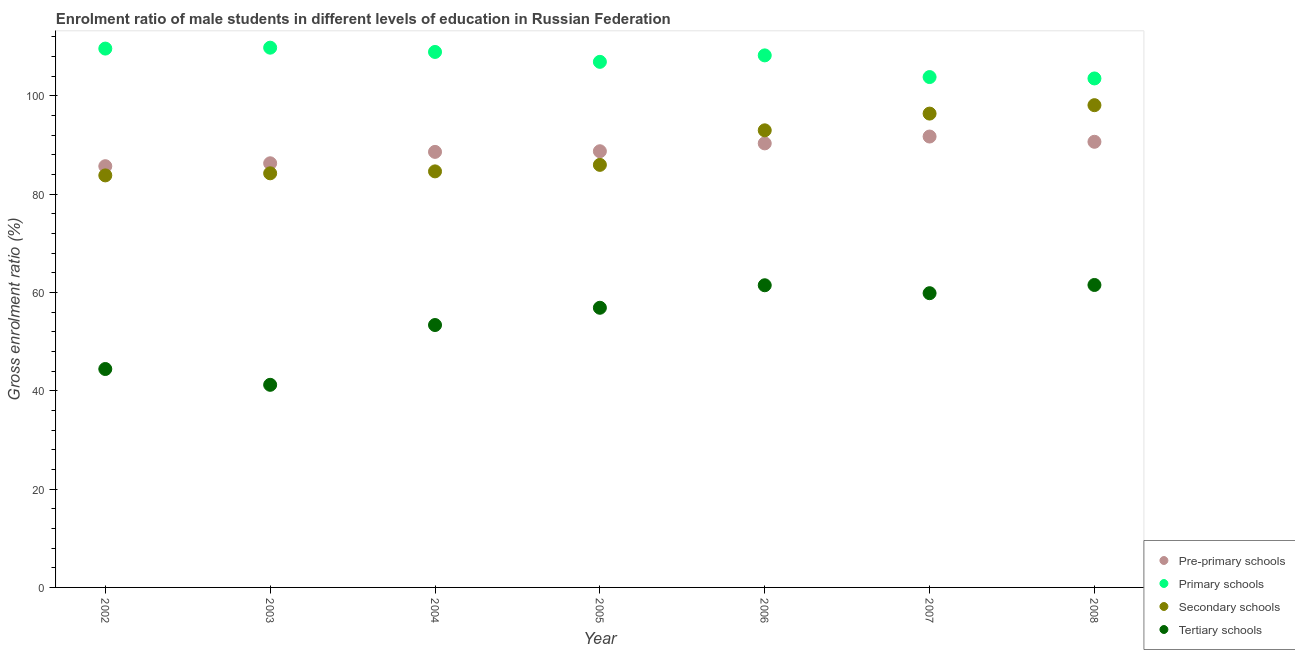How many different coloured dotlines are there?
Provide a short and direct response. 4. Is the number of dotlines equal to the number of legend labels?
Offer a terse response. Yes. What is the gross enrolment ratio(female) in pre-primary schools in 2005?
Your response must be concise. 88.73. Across all years, what is the maximum gross enrolment ratio(female) in pre-primary schools?
Provide a short and direct response. 91.72. Across all years, what is the minimum gross enrolment ratio(female) in primary schools?
Provide a succinct answer. 103.53. In which year was the gross enrolment ratio(female) in secondary schools maximum?
Keep it short and to the point. 2008. In which year was the gross enrolment ratio(female) in pre-primary schools minimum?
Keep it short and to the point. 2002. What is the total gross enrolment ratio(female) in tertiary schools in the graph?
Your answer should be compact. 378.75. What is the difference between the gross enrolment ratio(female) in primary schools in 2005 and that in 2008?
Your response must be concise. 3.38. What is the difference between the gross enrolment ratio(female) in tertiary schools in 2003 and the gross enrolment ratio(female) in secondary schools in 2004?
Ensure brevity in your answer.  -43.42. What is the average gross enrolment ratio(female) in secondary schools per year?
Keep it short and to the point. 89.44. In the year 2007, what is the difference between the gross enrolment ratio(female) in primary schools and gross enrolment ratio(female) in secondary schools?
Offer a terse response. 7.43. In how many years, is the gross enrolment ratio(female) in secondary schools greater than 96 %?
Ensure brevity in your answer.  2. What is the ratio of the gross enrolment ratio(female) in pre-primary schools in 2004 to that in 2006?
Your answer should be compact. 0.98. Is the gross enrolment ratio(female) in secondary schools in 2005 less than that in 2008?
Make the answer very short. Yes. Is the difference between the gross enrolment ratio(female) in secondary schools in 2002 and 2007 greater than the difference between the gross enrolment ratio(female) in tertiary schools in 2002 and 2007?
Provide a succinct answer. Yes. What is the difference between the highest and the second highest gross enrolment ratio(female) in secondary schools?
Keep it short and to the point. 1.71. What is the difference between the highest and the lowest gross enrolment ratio(female) in primary schools?
Ensure brevity in your answer.  6.26. In how many years, is the gross enrolment ratio(female) in primary schools greater than the average gross enrolment ratio(female) in primary schools taken over all years?
Ensure brevity in your answer.  4. Is it the case that in every year, the sum of the gross enrolment ratio(female) in pre-primary schools and gross enrolment ratio(female) in primary schools is greater than the gross enrolment ratio(female) in secondary schools?
Keep it short and to the point. Yes. Does the gross enrolment ratio(female) in pre-primary schools monotonically increase over the years?
Offer a terse response. No. How many dotlines are there?
Ensure brevity in your answer.  4. Are the values on the major ticks of Y-axis written in scientific E-notation?
Your answer should be compact. No. Does the graph contain any zero values?
Keep it short and to the point. No. Where does the legend appear in the graph?
Keep it short and to the point. Bottom right. What is the title of the graph?
Your answer should be very brief. Enrolment ratio of male students in different levels of education in Russian Federation. Does "Argument" appear as one of the legend labels in the graph?
Offer a terse response. No. What is the Gross enrolment ratio (%) of Pre-primary schools in 2002?
Your response must be concise. 85.69. What is the Gross enrolment ratio (%) in Primary schools in 2002?
Offer a terse response. 109.61. What is the Gross enrolment ratio (%) in Secondary schools in 2002?
Keep it short and to the point. 83.81. What is the Gross enrolment ratio (%) in Tertiary schools in 2002?
Provide a succinct answer. 44.43. What is the Gross enrolment ratio (%) of Pre-primary schools in 2003?
Your response must be concise. 86.28. What is the Gross enrolment ratio (%) in Primary schools in 2003?
Make the answer very short. 109.79. What is the Gross enrolment ratio (%) of Secondary schools in 2003?
Keep it short and to the point. 84.24. What is the Gross enrolment ratio (%) in Tertiary schools in 2003?
Your answer should be very brief. 41.21. What is the Gross enrolment ratio (%) in Pre-primary schools in 2004?
Your response must be concise. 88.6. What is the Gross enrolment ratio (%) of Primary schools in 2004?
Ensure brevity in your answer.  108.93. What is the Gross enrolment ratio (%) in Secondary schools in 2004?
Offer a very short reply. 84.63. What is the Gross enrolment ratio (%) in Tertiary schools in 2004?
Offer a terse response. 53.38. What is the Gross enrolment ratio (%) of Pre-primary schools in 2005?
Your answer should be compact. 88.73. What is the Gross enrolment ratio (%) in Primary schools in 2005?
Offer a terse response. 106.91. What is the Gross enrolment ratio (%) of Secondary schools in 2005?
Keep it short and to the point. 85.96. What is the Gross enrolment ratio (%) of Tertiary schools in 2005?
Give a very brief answer. 56.89. What is the Gross enrolment ratio (%) in Pre-primary schools in 2006?
Give a very brief answer. 90.33. What is the Gross enrolment ratio (%) of Primary schools in 2006?
Your answer should be very brief. 108.23. What is the Gross enrolment ratio (%) of Secondary schools in 2006?
Your answer should be compact. 92.98. What is the Gross enrolment ratio (%) of Tertiary schools in 2006?
Make the answer very short. 61.47. What is the Gross enrolment ratio (%) in Pre-primary schools in 2007?
Your response must be concise. 91.72. What is the Gross enrolment ratio (%) in Primary schools in 2007?
Your answer should be compact. 103.82. What is the Gross enrolment ratio (%) in Secondary schools in 2007?
Your answer should be compact. 96.38. What is the Gross enrolment ratio (%) of Tertiary schools in 2007?
Your answer should be compact. 59.85. What is the Gross enrolment ratio (%) of Pre-primary schools in 2008?
Ensure brevity in your answer.  90.65. What is the Gross enrolment ratio (%) in Primary schools in 2008?
Your response must be concise. 103.53. What is the Gross enrolment ratio (%) in Secondary schools in 2008?
Provide a succinct answer. 98.1. What is the Gross enrolment ratio (%) in Tertiary schools in 2008?
Ensure brevity in your answer.  61.52. Across all years, what is the maximum Gross enrolment ratio (%) in Pre-primary schools?
Provide a short and direct response. 91.72. Across all years, what is the maximum Gross enrolment ratio (%) of Primary schools?
Provide a succinct answer. 109.79. Across all years, what is the maximum Gross enrolment ratio (%) in Secondary schools?
Offer a very short reply. 98.1. Across all years, what is the maximum Gross enrolment ratio (%) in Tertiary schools?
Make the answer very short. 61.52. Across all years, what is the minimum Gross enrolment ratio (%) in Pre-primary schools?
Provide a succinct answer. 85.69. Across all years, what is the minimum Gross enrolment ratio (%) in Primary schools?
Offer a terse response. 103.53. Across all years, what is the minimum Gross enrolment ratio (%) of Secondary schools?
Your answer should be very brief. 83.81. Across all years, what is the minimum Gross enrolment ratio (%) of Tertiary schools?
Ensure brevity in your answer.  41.21. What is the total Gross enrolment ratio (%) of Pre-primary schools in the graph?
Your response must be concise. 621.99. What is the total Gross enrolment ratio (%) in Primary schools in the graph?
Give a very brief answer. 750.82. What is the total Gross enrolment ratio (%) in Secondary schools in the graph?
Provide a succinct answer. 626.11. What is the total Gross enrolment ratio (%) in Tertiary schools in the graph?
Give a very brief answer. 378.75. What is the difference between the Gross enrolment ratio (%) in Pre-primary schools in 2002 and that in 2003?
Provide a short and direct response. -0.59. What is the difference between the Gross enrolment ratio (%) of Primary schools in 2002 and that in 2003?
Your answer should be very brief. -0.18. What is the difference between the Gross enrolment ratio (%) of Secondary schools in 2002 and that in 2003?
Keep it short and to the point. -0.42. What is the difference between the Gross enrolment ratio (%) in Tertiary schools in 2002 and that in 2003?
Make the answer very short. 3.22. What is the difference between the Gross enrolment ratio (%) of Pre-primary schools in 2002 and that in 2004?
Provide a succinct answer. -2.91. What is the difference between the Gross enrolment ratio (%) in Primary schools in 2002 and that in 2004?
Keep it short and to the point. 0.68. What is the difference between the Gross enrolment ratio (%) in Secondary schools in 2002 and that in 2004?
Give a very brief answer. -0.82. What is the difference between the Gross enrolment ratio (%) of Tertiary schools in 2002 and that in 2004?
Keep it short and to the point. -8.95. What is the difference between the Gross enrolment ratio (%) in Pre-primary schools in 2002 and that in 2005?
Give a very brief answer. -3.04. What is the difference between the Gross enrolment ratio (%) of Primary schools in 2002 and that in 2005?
Provide a succinct answer. 2.7. What is the difference between the Gross enrolment ratio (%) in Secondary schools in 2002 and that in 2005?
Keep it short and to the point. -2.14. What is the difference between the Gross enrolment ratio (%) in Tertiary schools in 2002 and that in 2005?
Make the answer very short. -12.46. What is the difference between the Gross enrolment ratio (%) of Pre-primary schools in 2002 and that in 2006?
Make the answer very short. -4.64. What is the difference between the Gross enrolment ratio (%) in Primary schools in 2002 and that in 2006?
Your response must be concise. 1.38. What is the difference between the Gross enrolment ratio (%) of Secondary schools in 2002 and that in 2006?
Offer a terse response. -9.17. What is the difference between the Gross enrolment ratio (%) in Tertiary schools in 2002 and that in 2006?
Give a very brief answer. -17.04. What is the difference between the Gross enrolment ratio (%) in Pre-primary schools in 2002 and that in 2007?
Ensure brevity in your answer.  -6.03. What is the difference between the Gross enrolment ratio (%) in Primary schools in 2002 and that in 2007?
Your response must be concise. 5.79. What is the difference between the Gross enrolment ratio (%) in Secondary schools in 2002 and that in 2007?
Your answer should be compact. -12.57. What is the difference between the Gross enrolment ratio (%) in Tertiary schools in 2002 and that in 2007?
Offer a terse response. -15.42. What is the difference between the Gross enrolment ratio (%) in Pre-primary schools in 2002 and that in 2008?
Offer a terse response. -4.96. What is the difference between the Gross enrolment ratio (%) of Primary schools in 2002 and that in 2008?
Provide a succinct answer. 6.08. What is the difference between the Gross enrolment ratio (%) in Secondary schools in 2002 and that in 2008?
Provide a succinct answer. -14.28. What is the difference between the Gross enrolment ratio (%) of Tertiary schools in 2002 and that in 2008?
Offer a very short reply. -17.09. What is the difference between the Gross enrolment ratio (%) of Pre-primary schools in 2003 and that in 2004?
Your answer should be very brief. -2.32. What is the difference between the Gross enrolment ratio (%) in Primary schools in 2003 and that in 2004?
Your response must be concise. 0.87. What is the difference between the Gross enrolment ratio (%) in Secondary schools in 2003 and that in 2004?
Provide a short and direct response. -0.39. What is the difference between the Gross enrolment ratio (%) of Tertiary schools in 2003 and that in 2004?
Provide a succinct answer. -12.16. What is the difference between the Gross enrolment ratio (%) in Pre-primary schools in 2003 and that in 2005?
Give a very brief answer. -2.45. What is the difference between the Gross enrolment ratio (%) in Primary schools in 2003 and that in 2005?
Keep it short and to the point. 2.88. What is the difference between the Gross enrolment ratio (%) in Secondary schools in 2003 and that in 2005?
Keep it short and to the point. -1.72. What is the difference between the Gross enrolment ratio (%) of Tertiary schools in 2003 and that in 2005?
Your answer should be compact. -15.67. What is the difference between the Gross enrolment ratio (%) of Pre-primary schools in 2003 and that in 2006?
Your answer should be very brief. -4.05. What is the difference between the Gross enrolment ratio (%) of Primary schools in 2003 and that in 2006?
Make the answer very short. 1.57. What is the difference between the Gross enrolment ratio (%) in Secondary schools in 2003 and that in 2006?
Offer a terse response. -8.75. What is the difference between the Gross enrolment ratio (%) in Tertiary schools in 2003 and that in 2006?
Your answer should be compact. -20.25. What is the difference between the Gross enrolment ratio (%) of Pre-primary schools in 2003 and that in 2007?
Keep it short and to the point. -5.44. What is the difference between the Gross enrolment ratio (%) in Primary schools in 2003 and that in 2007?
Keep it short and to the point. 5.97. What is the difference between the Gross enrolment ratio (%) of Secondary schools in 2003 and that in 2007?
Give a very brief answer. -12.15. What is the difference between the Gross enrolment ratio (%) in Tertiary schools in 2003 and that in 2007?
Provide a short and direct response. -18.64. What is the difference between the Gross enrolment ratio (%) of Pre-primary schools in 2003 and that in 2008?
Give a very brief answer. -4.37. What is the difference between the Gross enrolment ratio (%) in Primary schools in 2003 and that in 2008?
Your response must be concise. 6.26. What is the difference between the Gross enrolment ratio (%) in Secondary schools in 2003 and that in 2008?
Make the answer very short. -13.86. What is the difference between the Gross enrolment ratio (%) of Tertiary schools in 2003 and that in 2008?
Make the answer very short. -20.31. What is the difference between the Gross enrolment ratio (%) in Pre-primary schools in 2004 and that in 2005?
Provide a succinct answer. -0.13. What is the difference between the Gross enrolment ratio (%) in Primary schools in 2004 and that in 2005?
Ensure brevity in your answer.  2.01. What is the difference between the Gross enrolment ratio (%) in Secondary schools in 2004 and that in 2005?
Your answer should be very brief. -1.32. What is the difference between the Gross enrolment ratio (%) in Tertiary schools in 2004 and that in 2005?
Offer a very short reply. -3.51. What is the difference between the Gross enrolment ratio (%) of Pre-primary schools in 2004 and that in 2006?
Make the answer very short. -1.73. What is the difference between the Gross enrolment ratio (%) in Primary schools in 2004 and that in 2006?
Offer a very short reply. 0.7. What is the difference between the Gross enrolment ratio (%) in Secondary schools in 2004 and that in 2006?
Offer a very short reply. -8.35. What is the difference between the Gross enrolment ratio (%) of Tertiary schools in 2004 and that in 2006?
Make the answer very short. -8.09. What is the difference between the Gross enrolment ratio (%) in Pre-primary schools in 2004 and that in 2007?
Offer a very short reply. -3.12. What is the difference between the Gross enrolment ratio (%) of Primary schools in 2004 and that in 2007?
Offer a terse response. 5.11. What is the difference between the Gross enrolment ratio (%) in Secondary schools in 2004 and that in 2007?
Keep it short and to the point. -11.75. What is the difference between the Gross enrolment ratio (%) in Tertiary schools in 2004 and that in 2007?
Provide a short and direct response. -6.48. What is the difference between the Gross enrolment ratio (%) in Pre-primary schools in 2004 and that in 2008?
Provide a succinct answer. -2.05. What is the difference between the Gross enrolment ratio (%) of Primary schools in 2004 and that in 2008?
Your answer should be very brief. 5.39. What is the difference between the Gross enrolment ratio (%) of Secondary schools in 2004 and that in 2008?
Your response must be concise. -13.47. What is the difference between the Gross enrolment ratio (%) in Tertiary schools in 2004 and that in 2008?
Your answer should be very brief. -8.15. What is the difference between the Gross enrolment ratio (%) in Pre-primary schools in 2005 and that in 2006?
Ensure brevity in your answer.  -1.6. What is the difference between the Gross enrolment ratio (%) of Primary schools in 2005 and that in 2006?
Your answer should be compact. -1.32. What is the difference between the Gross enrolment ratio (%) in Secondary schools in 2005 and that in 2006?
Give a very brief answer. -7.03. What is the difference between the Gross enrolment ratio (%) in Tertiary schools in 2005 and that in 2006?
Your answer should be compact. -4.58. What is the difference between the Gross enrolment ratio (%) in Pre-primary schools in 2005 and that in 2007?
Offer a very short reply. -2.99. What is the difference between the Gross enrolment ratio (%) of Primary schools in 2005 and that in 2007?
Keep it short and to the point. 3.09. What is the difference between the Gross enrolment ratio (%) in Secondary schools in 2005 and that in 2007?
Your answer should be very brief. -10.43. What is the difference between the Gross enrolment ratio (%) in Tertiary schools in 2005 and that in 2007?
Give a very brief answer. -2.97. What is the difference between the Gross enrolment ratio (%) of Pre-primary schools in 2005 and that in 2008?
Your answer should be compact. -1.92. What is the difference between the Gross enrolment ratio (%) in Primary schools in 2005 and that in 2008?
Offer a very short reply. 3.38. What is the difference between the Gross enrolment ratio (%) in Secondary schools in 2005 and that in 2008?
Keep it short and to the point. -12.14. What is the difference between the Gross enrolment ratio (%) in Tertiary schools in 2005 and that in 2008?
Make the answer very short. -4.64. What is the difference between the Gross enrolment ratio (%) of Pre-primary schools in 2006 and that in 2007?
Provide a short and direct response. -1.39. What is the difference between the Gross enrolment ratio (%) of Primary schools in 2006 and that in 2007?
Offer a very short reply. 4.41. What is the difference between the Gross enrolment ratio (%) of Secondary schools in 2006 and that in 2007?
Provide a short and direct response. -3.4. What is the difference between the Gross enrolment ratio (%) of Tertiary schools in 2006 and that in 2007?
Give a very brief answer. 1.61. What is the difference between the Gross enrolment ratio (%) in Pre-primary schools in 2006 and that in 2008?
Offer a terse response. -0.32. What is the difference between the Gross enrolment ratio (%) of Primary schools in 2006 and that in 2008?
Provide a succinct answer. 4.69. What is the difference between the Gross enrolment ratio (%) of Secondary schools in 2006 and that in 2008?
Ensure brevity in your answer.  -5.12. What is the difference between the Gross enrolment ratio (%) in Tertiary schools in 2006 and that in 2008?
Keep it short and to the point. -0.06. What is the difference between the Gross enrolment ratio (%) in Pre-primary schools in 2007 and that in 2008?
Offer a very short reply. 1.07. What is the difference between the Gross enrolment ratio (%) in Primary schools in 2007 and that in 2008?
Your answer should be compact. 0.28. What is the difference between the Gross enrolment ratio (%) of Secondary schools in 2007 and that in 2008?
Your answer should be very brief. -1.71. What is the difference between the Gross enrolment ratio (%) of Tertiary schools in 2007 and that in 2008?
Your answer should be very brief. -1.67. What is the difference between the Gross enrolment ratio (%) in Pre-primary schools in 2002 and the Gross enrolment ratio (%) in Primary schools in 2003?
Your answer should be very brief. -24.11. What is the difference between the Gross enrolment ratio (%) in Pre-primary schools in 2002 and the Gross enrolment ratio (%) in Secondary schools in 2003?
Make the answer very short. 1.45. What is the difference between the Gross enrolment ratio (%) of Pre-primary schools in 2002 and the Gross enrolment ratio (%) of Tertiary schools in 2003?
Your answer should be very brief. 44.47. What is the difference between the Gross enrolment ratio (%) in Primary schools in 2002 and the Gross enrolment ratio (%) in Secondary schools in 2003?
Offer a very short reply. 25.37. What is the difference between the Gross enrolment ratio (%) in Primary schools in 2002 and the Gross enrolment ratio (%) in Tertiary schools in 2003?
Ensure brevity in your answer.  68.4. What is the difference between the Gross enrolment ratio (%) of Secondary schools in 2002 and the Gross enrolment ratio (%) of Tertiary schools in 2003?
Provide a short and direct response. 42.6. What is the difference between the Gross enrolment ratio (%) of Pre-primary schools in 2002 and the Gross enrolment ratio (%) of Primary schools in 2004?
Your response must be concise. -23.24. What is the difference between the Gross enrolment ratio (%) of Pre-primary schools in 2002 and the Gross enrolment ratio (%) of Secondary schools in 2004?
Your response must be concise. 1.05. What is the difference between the Gross enrolment ratio (%) in Pre-primary schools in 2002 and the Gross enrolment ratio (%) in Tertiary schools in 2004?
Make the answer very short. 32.31. What is the difference between the Gross enrolment ratio (%) in Primary schools in 2002 and the Gross enrolment ratio (%) in Secondary schools in 2004?
Keep it short and to the point. 24.98. What is the difference between the Gross enrolment ratio (%) of Primary schools in 2002 and the Gross enrolment ratio (%) of Tertiary schools in 2004?
Ensure brevity in your answer.  56.23. What is the difference between the Gross enrolment ratio (%) of Secondary schools in 2002 and the Gross enrolment ratio (%) of Tertiary schools in 2004?
Make the answer very short. 30.44. What is the difference between the Gross enrolment ratio (%) in Pre-primary schools in 2002 and the Gross enrolment ratio (%) in Primary schools in 2005?
Your response must be concise. -21.23. What is the difference between the Gross enrolment ratio (%) of Pre-primary schools in 2002 and the Gross enrolment ratio (%) of Secondary schools in 2005?
Provide a succinct answer. -0.27. What is the difference between the Gross enrolment ratio (%) of Pre-primary schools in 2002 and the Gross enrolment ratio (%) of Tertiary schools in 2005?
Your answer should be compact. 28.8. What is the difference between the Gross enrolment ratio (%) in Primary schools in 2002 and the Gross enrolment ratio (%) in Secondary schools in 2005?
Your answer should be compact. 23.65. What is the difference between the Gross enrolment ratio (%) in Primary schools in 2002 and the Gross enrolment ratio (%) in Tertiary schools in 2005?
Offer a very short reply. 52.72. What is the difference between the Gross enrolment ratio (%) of Secondary schools in 2002 and the Gross enrolment ratio (%) of Tertiary schools in 2005?
Offer a terse response. 26.93. What is the difference between the Gross enrolment ratio (%) of Pre-primary schools in 2002 and the Gross enrolment ratio (%) of Primary schools in 2006?
Your answer should be very brief. -22.54. What is the difference between the Gross enrolment ratio (%) of Pre-primary schools in 2002 and the Gross enrolment ratio (%) of Secondary schools in 2006?
Ensure brevity in your answer.  -7.3. What is the difference between the Gross enrolment ratio (%) of Pre-primary schools in 2002 and the Gross enrolment ratio (%) of Tertiary schools in 2006?
Offer a very short reply. 24.22. What is the difference between the Gross enrolment ratio (%) in Primary schools in 2002 and the Gross enrolment ratio (%) in Secondary schools in 2006?
Offer a very short reply. 16.63. What is the difference between the Gross enrolment ratio (%) of Primary schools in 2002 and the Gross enrolment ratio (%) of Tertiary schools in 2006?
Provide a succinct answer. 48.14. What is the difference between the Gross enrolment ratio (%) in Secondary schools in 2002 and the Gross enrolment ratio (%) in Tertiary schools in 2006?
Your answer should be very brief. 22.35. What is the difference between the Gross enrolment ratio (%) in Pre-primary schools in 2002 and the Gross enrolment ratio (%) in Primary schools in 2007?
Your answer should be very brief. -18.13. What is the difference between the Gross enrolment ratio (%) of Pre-primary schools in 2002 and the Gross enrolment ratio (%) of Secondary schools in 2007?
Make the answer very short. -10.7. What is the difference between the Gross enrolment ratio (%) of Pre-primary schools in 2002 and the Gross enrolment ratio (%) of Tertiary schools in 2007?
Provide a short and direct response. 25.83. What is the difference between the Gross enrolment ratio (%) in Primary schools in 2002 and the Gross enrolment ratio (%) in Secondary schools in 2007?
Give a very brief answer. 13.23. What is the difference between the Gross enrolment ratio (%) in Primary schools in 2002 and the Gross enrolment ratio (%) in Tertiary schools in 2007?
Your answer should be compact. 49.76. What is the difference between the Gross enrolment ratio (%) of Secondary schools in 2002 and the Gross enrolment ratio (%) of Tertiary schools in 2007?
Make the answer very short. 23.96. What is the difference between the Gross enrolment ratio (%) in Pre-primary schools in 2002 and the Gross enrolment ratio (%) in Primary schools in 2008?
Your answer should be very brief. -17.85. What is the difference between the Gross enrolment ratio (%) of Pre-primary schools in 2002 and the Gross enrolment ratio (%) of Secondary schools in 2008?
Your answer should be very brief. -12.41. What is the difference between the Gross enrolment ratio (%) in Pre-primary schools in 2002 and the Gross enrolment ratio (%) in Tertiary schools in 2008?
Ensure brevity in your answer.  24.16. What is the difference between the Gross enrolment ratio (%) of Primary schools in 2002 and the Gross enrolment ratio (%) of Secondary schools in 2008?
Give a very brief answer. 11.51. What is the difference between the Gross enrolment ratio (%) in Primary schools in 2002 and the Gross enrolment ratio (%) in Tertiary schools in 2008?
Keep it short and to the point. 48.09. What is the difference between the Gross enrolment ratio (%) in Secondary schools in 2002 and the Gross enrolment ratio (%) in Tertiary schools in 2008?
Provide a succinct answer. 22.29. What is the difference between the Gross enrolment ratio (%) in Pre-primary schools in 2003 and the Gross enrolment ratio (%) in Primary schools in 2004?
Offer a very short reply. -22.65. What is the difference between the Gross enrolment ratio (%) in Pre-primary schools in 2003 and the Gross enrolment ratio (%) in Secondary schools in 2004?
Make the answer very short. 1.65. What is the difference between the Gross enrolment ratio (%) of Pre-primary schools in 2003 and the Gross enrolment ratio (%) of Tertiary schools in 2004?
Your response must be concise. 32.9. What is the difference between the Gross enrolment ratio (%) in Primary schools in 2003 and the Gross enrolment ratio (%) in Secondary schools in 2004?
Your answer should be compact. 25.16. What is the difference between the Gross enrolment ratio (%) of Primary schools in 2003 and the Gross enrolment ratio (%) of Tertiary schools in 2004?
Offer a terse response. 56.42. What is the difference between the Gross enrolment ratio (%) of Secondary schools in 2003 and the Gross enrolment ratio (%) of Tertiary schools in 2004?
Provide a succinct answer. 30.86. What is the difference between the Gross enrolment ratio (%) of Pre-primary schools in 2003 and the Gross enrolment ratio (%) of Primary schools in 2005?
Your response must be concise. -20.63. What is the difference between the Gross enrolment ratio (%) in Pre-primary schools in 2003 and the Gross enrolment ratio (%) in Secondary schools in 2005?
Your response must be concise. 0.32. What is the difference between the Gross enrolment ratio (%) in Pre-primary schools in 2003 and the Gross enrolment ratio (%) in Tertiary schools in 2005?
Give a very brief answer. 29.39. What is the difference between the Gross enrolment ratio (%) in Primary schools in 2003 and the Gross enrolment ratio (%) in Secondary schools in 2005?
Your answer should be very brief. 23.84. What is the difference between the Gross enrolment ratio (%) of Primary schools in 2003 and the Gross enrolment ratio (%) of Tertiary schools in 2005?
Your response must be concise. 52.91. What is the difference between the Gross enrolment ratio (%) of Secondary schools in 2003 and the Gross enrolment ratio (%) of Tertiary schools in 2005?
Make the answer very short. 27.35. What is the difference between the Gross enrolment ratio (%) in Pre-primary schools in 2003 and the Gross enrolment ratio (%) in Primary schools in 2006?
Provide a succinct answer. -21.95. What is the difference between the Gross enrolment ratio (%) in Pre-primary schools in 2003 and the Gross enrolment ratio (%) in Secondary schools in 2006?
Your answer should be compact. -6.7. What is the difference between the Gross enrolment ratio (%) in Pre-primary schools in 2003 and the Gross enrolment ratio (%) in Tertiary schools in 2006?
Ensure brevity in your answer.  24.81. What is the difference between the Gross enrolment ratio (%) in Primary schools in 2003 and the Gross enrolment ratio (%) in Secondary schools in 2006?
Your answer should be compact. 16.81. What is the difference between the Gross enrolment ratio (%) in Primary schools in 2003 and the Gross enrolment ratio (%) in Tertiary schools in 2006?
Offer a very short reply. 48.33. What is the difference between the Gross enrolment ratio (%) in Secondary schools in 2003 and the Gross enrolment ratio (%) in Tertiary schools in 2006?
Ensure brevity in your answer.  22.77. What is the difference between the Gross enrolment ratio (%) in Pre-primary schools in 2003 and the Gross enrolment ratio (%) in Primary schools in 2007?
Provide a short and direct response. -17.54. What is the difference between the Gross enrolment ratio (%) in Pre-primary schools in 2003 and the Gross enrolment ratio (%) in Secondary schools in 2007?
Your response must be concise. -10.11. What is the difference between the Gross enrolment ratio (%) of Pre-primary schools in 2003 and the Gross enrolment ratio (%) of Tertiary schools in 2007?
Provide a short and direct response. 26.43. What is the difference between the Gross enrolment ratio (%) of Primary schools in 2003 and the Gross enrolment ratio (%) of Secondary schools in 2007?
Ensure brevity in your answer.  13.41. What is the difference between the Gross enrolment ratio (%) of Primary schools in 2003 and the Gross enrolment ratio (%) of Tertiary schools in 2007?
Ensure brevity in your answer.  49.94. What is the difference between the Gross enrolment ratio (%) of Secondary schools in 2003 and the Gross enrolment ratio (%) of Tertiary schools in 2007?
Ensure brevity in your answer.  24.38. What is the difference between the Gross enrolment ratio (%) in Pre-primary schools in 2003 and the Gross enrolment ratio (%) in Primary schools in 2008?
Make the answer very short. -17.26. What is the difference between the Gross enrolment ratio (%) in Pre-primary schools in 2003 and the Gross enrolment ratio (%) in Secondary schools in 2008?
Ensure brevity in your answer.  -11.82. What is the difference between the Gross enrolment ratio (%) in Pre-primary schools in 2003 and the Gross enrolment ratio (%) in Tertiary schools in 2008?
Provide a succinct answer. 24.76. What is the difference between the Gross enrolment ratio (%) in Primary schools in 2003 and the Gross enrolment ratio (%) in Secondary schools in 2008?
Ensure brevity in your answer.  11.69. What is the difference between the Gross enrolment ratio (%) in Primary schools in 2003 and the Gross enrolment ratio (%) in Tertiary schools in 2008?
Offer a terse response. 48.27. What is the difference between the Gross enrolment ratio (%) in Secondary schools in 2003 and the Gross enrolment ratio (%) in Tertiary schools in 2008?
Keep it short and to the point. 22.71. What is the difference between the Gross enrolment ratio (%) of Pre-primary schools in 2004 and the Gross enrolment ratio (%) of Primary schools in 2005?
Make the answer very short. -18.31. What is the difference between the Gross enrolment ratio (%) in Pre-primary schools in 2004 and the Gross enrolment ratio (%) in Secondary schools in 2005?
Make the answer very short. 2.64. What is the difference between the Gross enrolment ratio (%) of Pre-primary schools in 2004 and the Gross enrolment ratio (%) of Tertiary schools in 2005?
Make the answer very short. 31.71. What is the difference between the Gross enrolment ratio (%) of Primary schools in 2004 and the Gross enrolment ratio (%) of Secondary schools in 2005?
Provide a succinct answer. 22.97. What is the difference between the Gross enrolment ratio (%) in Primary schools in 2004 and the Gross enrolment ratio (%) in Tertiary schools in 2005?
Your answer should be compact. 52.04. What is the difference between the Gross enrolment ratio (%) of Secondary schools in 2004 and the Gross enrolment ratio (%) of Tertiary schools in 2005?
Provide a short and direct response. 27.74. What is the difference between the Gross enrolment ratio (%) of Pre-primary schools in 2004 and the Gross enrolment ratio (%) of Primary schools in 2006?
Your response must be concise. -19.63. What is the difference between the Gross enrolment ratio (%) in Pre-primary schools in 2004 and the Gross enrolment ratio (%) in Secondary schools in 2006?
Your answer should be compact. -4.39. What is the difference between the Gross enrolment ratio (%) in Pre-primary schools in 2004 and the Gross enrolment ratio (%) in Tertiary schools in 2006?
Your response must be concise. 27.13. What is the difference between the Gross enrolment ratio (%) in Primary schools in 2004 and the Gross enrolment ratio (%) in Secondary schools in 2006?
Ensure brevity in your answer.  15.94. What is the difference between the Gross enrolment ratio (%) in Primary schools in 2004 and the Gross enrolment ratio (%) in Tertiary schools in 2006?
Provide a succinct answer. 47.46. What is the difference between the Gross enrolment ratio (%) in Secondary schools in 2004 and the Gross enrolment ratio (%) in Tertiary schools in 2006?
Give a very brief answer. 23.16. What is the difference between the Gross enrolment ratio (%) in Pre-primary schools in 2004 and the Gross enrolment ratio (%) in Primary schools in 2007?
Offer a very short reply. -15.22. What is the difference between the Gross enrolment ratio (%) of Pre-primary schools in 2004 and the Gross enrolment ratio (%) of Secondary schools in 2007?
Provide a succinct answer. -7.79. What is the difference between the Gross enrolment ratio (%) in Pre-primary schools in 2004 and the Gross enrolment ratio (%) in Tertiary schools in 2007?
Provide a short and direct response. 28.74. What is the difference between the Gross enrolment ratio (%) of Primary schools in 2004 and the Gross enrolment ratio (%) of Secondary schools in 2007?
Offer a very short reply. 12.54. What is the difference between the Gross enrolment ratio (%) of Primary schools in 2004 and the Gross enrolment ratio (%) of Tertiary schools in 2007?
Make the answer very short. 49.07. What is the difference between the Gross enrolment ratio (%) in Secondary schools in 2004 and the Gross enrolment ratio (%) in Tertiary schools in 2007?
Ensure brevity in your answer.  24.78. What is the difference between the Gross enrolment ratio (%) in Pre-primary schools in 2004 and the Gross enrolment ratio (%) in Primary schools in 2008?
Offer a terse response. -14.94. What is the difference between the Gross enrolment ratio (%) of Pre-primary schools in 2004 and the Gross enrolment ratio (%) of Secondary schools in 2008?
Keep it short and to the point. -9.5. What is the difference between the Gross enrolment ratio (%) of Pre-primary schools in 2004 and the Gross enrolment ratio (%) of Tertiary schools in 2008?
Provide a short and direct response. 27.07. What is the difference between the Gross enrolment ratio (%) of Primary schools in 2004 and the Gross enrolment ratio (%) of Secondary schools in 2008?
Your answer should be compact. 10.83. What is the difference between the Gross enrolment ratio (%) of Primary schools in 2004 and the Gross enrolment ratio (%) of Tertiary schools in 2008?
Offer a very short reply. 47.4. What is the difference between the Gross enrolment ratio (%) in Secondary schools in 2004 and the Gross enrolment ratio (%) in Tertiary schools in 2008?
Make the answer very short. 23.11. What is the difference between the Gross enrolment ratio (%) in Pre-primary schools in 2005 and the Gross enrolment ratio (%) in Primary schools in 2006?
Provide a short and direct response. -19.5. What is the difference between the Gross enrolment ratio (%) in Pre-primary schools in 2005 and the Gross enrolment ratio (%) in Secondary schools in 2006?
Keep it short and to the point. -4.25. What is the difference between the Gross enrolment ratio (%) of Pre-primary schools in 2005 and the Gross enrolment ratio (%) of Tertiary schools in 2006?
Give a very brief answer. 27.26. What is the difference between the Gross enrolment ratio (%) in Primary schools in 2005 and the Gross enrolment ratio (%) in Secondary schools in 2006?
Provide a succinct answer. 13.93. What is the difference between the Gross enrolment ratio (%) of Primary schools in 2005 and the Gross enrolment ratio (%) of Tertiary schools in 2006?
Ensure brevity in your answer.  45.44. What is the difference between the Gross enrolment ratio (%) of Secondary schools in 2005 and the Gross enrolment ratio (%) of Tertiary schools in 2006?
Give a very brief answer. 24.49. What is the difference between the Gross enrolment ratio (%) in Pre-primary schools in 2005 and the Gross enrolment ratio (%) in Primary schools in 2007?
Offer a very short reply. -15.09. What is the difference between the Gross enrolment ratio (%) in Pre-primary schools in 2005 and the Gross enrolment ratio (%) in Secondary schools in 2007?
Make the answer very short. -7.66. What is the difference between the Gross enrolment ratio (%) of Pre-primary schools in 2005 and the Gross enrolment ratio (%) of Tertiary schools in 2007?
Offer a very short reply. 28.88. What is the difference between the Gross enrolment ratio (%) of Primary schools in 2005 and the Gross enrolment ratio (%) of Secondary schools in 2007?
Your answer should be very brief. 10.53. What is the difference between the Gross enrolment ratio (%) of Primary schools in 2005 and the Gross enrolment ratio (%) of Tertiary schools in 2007?
Your response must be concise. 47.06. What is the difference between the Gross enrolment ratio (%) of Secondary schools in 2005 and the Gross enrolment ratio (%) of Tertiary schools in 2007?
Keep it short and to the point. 26.1. What is the difference between the Gross enrolment ratio (%) of Pre-primary schools in 2005 and the Gross enrolment ratio (%) of Primary schools in 2008?
Provide a short and direct response. -14.81. What is the difference between the Gross enrolment ratio (%) of Pre-primary schools in 2005 and the Gross enrolment ratio (%) of Secondary schools in 2008?
Provide a succinct answer. -9.37. What is the difference between the Gross enrolment ratio (%) of Pre-primary schools in 2005 and the Gross enrolment ratio (%) of Tertiary schools in 2008?
Your answer should be very brief. 27.2. What is the difference between the Gross enrolment ratio (%) of Primary schools in 2005 and the Gross enrolment ratio (%) of Secondary schools in 2008?
Provide a short and direct response. 8.81. What is the difference between the Gross enrolment ratio (%) of Primary schools in 2005 and the Gross enrolment ratio (%) of Tertiary schools in 2008?
Provide a succinct answer. 45.39. What is the difference between the Gross enrolment ratio (%) in Secondary schools in 2005 and the Gross enrolment ratio (%) in Tertiary schools in 2008?
Keep it short and to the point. 24.43. What is the difference between the Gross enrolment ratio (%) of Pre-primary schools in 2006 and the Gross enrolment ratio (%) of Primary schools in 2007?
Provide a succinct answer. -13.49. What is the difference between the Gross enrolment ratio (%) in Pre-primary schools in 2006 and the Gross enrolment ratio (%) in Secondary schools in 2007?
Offer a very short reply. -6.06. What is the difference between the Gross enrolment ratio (%) of Pre-primary schools in 2006 and the Gross enrolment ratio (%) of Tertiary schools in 2007?
Keep it short and to the point. 30.47. What is the difference between the Gross enrolment ratio (%) in Primary schools in 2006 and the Gross enrolment ratio (%) in Secondary schools in 2007?
Provide a succinct answer. 11.84. What is the difference between the Gross enrolment ratio (%) in Primary schools in 2006 and the Gross enrolment ratio (%) in Tertiary schools in 2007?
Your response must be concise. 48.37. What is the difference between the Gross enrolment ratio (%) in Secondary schools in 2006 and the Gross enrolment ratio (%) in Tertiary schools in 2007?
Provide a short and direct response. 33.13. What is the difference between the Gross enrolment ratio (%) in Pre-primary schools in 2006 and the Gross enrolment ratio (%) in Primary schools in 2008?
Ensure brevity in your answer.  -13.21. What is the difference between the Gross enrolment ratio (%) of Pre-primary schools in 2006 and the Gross enrolment ratio (%) of Secondary schools in 2008?
Give a very brief answer. -7.77. What is the difference between the Gross enrolment ratio (%) of Pre-primary schools in 2006 and the Gross enrolment ratio (%) of Tertiary schools in 2008?
Offer a very short reply. 28.8. What is the difference between the Gross enrolment ratio (%) of Primary schools in 2006 and the Gross enrolment ratio (%) of Secondary schools in 2008?
Make the answer very short. 10.13. What is the difference between the Gross enrolment ratio (%) in Primary schools in 2006 and the Gross enrolment ratio (%) in Tertiary schools in 2008?
Your answer should be very brief. 46.7. What is the difference between the Gross enrolment ratio (%) of Secondary schools in 2006 and the Gross enrolment ratio (%) of Tertiary schools in 2008?
Give a very brief answer. 31.46. What is the difference between the Gross enrolment ratio (%) of Pre-primary schools in 2007 and the Gross enrolment ratio (%) of Primary schools in 2008?
Your answer should be compact. -11.82. What is the difference between the Gross enrolment ratio (%) of Pre-primary schools in 2007 and the Gross enrolment ratio (%) of Secondary schools in 2008?
Provide a short and direct response. -6.38. What is the difference between the Gross enrolment ratio (%) of Pre-primary schools in 2007 and the Gross enrolment ratio (%) of Tertiary schools in 2008?
Make the answer very short. 30.2. What is the difference between the Gross enrolment ratio (%) in Primary schools in 2007 and the Gross enrolment ratio (%) in Secondary schools in 2008?
Make the answer very short. 5.72. What is the difference between the Gross enrolment ratio (%) of Primary schools in 2007 and the Gross enrolment ratio (%) of Tertiary schools in 2008?
Your answer should be compact. 42.3. What is the difference between the Gross enrolment ratio (%) in Secondary schools in 2007 and the Gross enrolment ratio (%) in Tertiary schools in 2008?
Give a very brief answer. 34.86. What is the average Gross enrolment ratio (%) of Pre-primary schools per year?
Your answer should be very brief. 88.86. What is the average Gross enrolment ratio (%) of Primary schools per year?
Offer a terse response. 107.26. What is the average Gross enrolment ratio (%) in Secondary schools per year?
Ensure brevity in your answer.  89.44. What is the average Gross enrolment ratio (%) in Tertiary schools per year?
Give a very brief answer. 54.11. In the year 2002, what is the difference between the Gross enrolment ratio (%) of Pre-primary schools and Gross enrolment ratio (%) of Primary schools?
Make the answer very short. -23.92. In the year 2002, what is the difference between the Gross enrolment ratio (%) in Pre-primary schools and Gross enrolment ratio (%) in Secondary schools?
Keep it short and to the point. 1.87. In the year 2002, what is the difference between the Gross enrolment ratio (%) in Pre-primary schools and Gross enrolment ratio (%) in Tertiary schools?
Offer a very short reply. 41.26. In the year 2002, what is the difference between the Gross enrolment ratio (%) of Primary schools and Gross enrolment ratio (%) of Secondary schools?
Your answer should be compact. 25.8. In the year 2002, what is the difference between the Gross enrolment ratio (%) in Primary schools and Gross enrolment ratio (%) in Tertiary schools?
Provide a short and direct response. 65.18. In the year 2002, what is the difference between the Gross enrolment ratio (%) in Secondary schools and Gross enrolment ratio (%) in Tertiary schools?
Your answer should be compact. 39.38. In the year 2003, what is the difference between the Gross enrolment ratio (%) in Pre-primary schools and Gross enrolment ratio (%) in Primary schools?
Ensure brevity in your answer.  -23.51. In the year 2003, what is the difference between the Gross enrolment ratio (%) in Pre-primary schools and Gross enrolment ratio (%) in Secondary schools?
Keep it short and to the point. 2.04. In the year 2003, what is the difference between the Gross enrolment ratio (%) of Pre-primary schools and Gross enrolment ratio (%) of Tertiary schools?
Make the answer very short. 45.07. In the year 2003, what is the difference between the Gross enrolment ratio (%) of Primary schools and Gross enrolment ratio (%) of Secondary schools?
Ensure brevity in your answer.  25.56. In the year 2003, what is the difference between the Gross enrolment ratio (%) of Primary schools and Gross enrolment ratio (%) of Tertiary schools?
Your answer should be very brief. 68.58. In the year 2003, what is the difference between the Gross enrolment ratio (%) in Secondary schools and Gross enrolment ratio (%) in Tertiary schools?
Provide a succinct answer. 43.02. In the year 2004, what is the difference between the Gross enrolment ratio (%) of Pre-primary schools and Gross enrolment ratio (%) of Primary schools?
Offer a very short reply. -20.33. In the year 2004, what is the difference between the Gross enrolment ratio (%) in Pre-primary schools and Gross enrolment ratio (%) in Secondary schools?
Offer a terse response. 3.97. In the year 2004, what is the difference between the Gross enrolment ratio (%) of Pre-primary schools and Gross enrolment ratio (%) of Tertiary schools?
Keep it short and to the point. 35.22. In the year 2004, what is the difference between the Gross enrolment ratio (%) in Primary schools and Gross enrolment ratio (%) in Secondary schools?
Offer a very short reply. 24.29. In the year 2004, what is the difference between the Gross enrolment ratio (%) of Primary schools and Gross enrolment ratio (%) of Tertiary schools?
Make the answer very short. 55.55. In the year 2004, what is the difference between the Gross enrolment ratio (%) of Secondary schools and Gross enrolment ratio (%) of Tertiary schools?
Give a very brief answer. 31.25. In the year 2005, what is the difference between the Gross enrolment ratio (%) in Pre-primary schools and Gross enrolment ratio (%) in Primary schools?
Your answer should be compact. -18.18. In the year 2005, what is the difference between the Gross enrolment ratio (%) in Pre-primary schools and Gross enrolment ratio (%) in Secondary schools?
Your response must be concise. 2.77. In the year 2005, what is the difference between the Gross enrolment ratio (%) in Pre-primary schools and Gross enrolment ratio (%) in Tertiary schools?
Your answer should be compact. 31.84. In the year 2005, what is the difference between the Gross enrolment ratio (%) of Primary schools and Gross enrolment ratio (%) of Secondary schools?
Provide a succinct answer. 20.96. In the year 2005, what is the difference between the Gross enrolment ratio (%) of Primary schools and Gross enrolment ratio (%) of Tertiary schools?
Provide a succinct answer. 50.03. In the year 2005, what is the difference between the Gross enrolment ratio (%) in Secondary schools and Gross enrolment ratio (%) in Tertiary schools?
Offer a very short reply. 29.07. In the year 2006, what is the difference between the Gross enrolment ratio (%) of Pre-primary schools and Gross enrolment ratio (%) of Primary schools?
Provide a short and direct response. -17.9. In the year 2006, what is the difference between the Gross enrolment ratio (%) of Pre-primary schools and Gross enrolment ratio (%) of Secondary schools?
Give a very brief answer. -2.66. In the year 2006, what is the difference between the Gross enrolment ratio (%) in Pre-primary schools and Gross enrolment ratio (%) in Tertiary schools?
Make the answer very short. 28.86. In the year 2006, what is the difference between the Gross enrolment ratio (%) in Primary schools and Gross enrolment ratio (%) in Secondary schools?
Provide a short and direct response. 15.24. In the year 2006, what is the difference between the Gross enrolment ratio (%) in Primary schools and Gross enrolment ratio (%) in Tertiary schools?
Give a very brief answer. 46.76. In the year 2006, what is the difference between the Gross enrolment ratio (%) in Secondary schools and Gross enrolment ratio (%) in Tertiary schools?
Make the answer very short. 31.52. In the year 2007, what is the difference between the Gross enrolment ratio (%) of Pre-primary schools and Gross enrolment ratio (%) of Primary schools?
Make the answer very short. -12.1. In the year 2007, what is the difference between the Gross enrolment ratio (%) in Pre-primary schools and Gross enrolment ratio (%) in Secondary schools?
Provide a succinct answer. -4.67. In the year 2007, what is the difference between the Gross enrolment ratio (%) in Pre-primary schools and Gross enrolment ratio (%) in Tertiary schools?
Give a very brief answer. 31.87. In the year 2007, what is the difference between the Gross enrolment ratio (%) in Primary schools and Gross enrolment ratio (%) in Secondary schools?
Give a very brief answer. 7.43. In the year 2007, what is the difference between the Gross enrolment ratio (%) in Primary schools and Gross enrolment ratio (%) in Tertiary schools?
Provide a succinct answer. 43.97. In the year 2007, what is the difference between the Gross enrolment ratio (%) in Secondary schools and Gross enrolment ratio (%) in Tertiary schools?
Provide a short and direct response. 36.53. In the year 2008, what is the difference between the Gross enrolment ratio (%) of Pre-primary schools and Gross enrolment ratio (%) of Primary schools?
Provide a succinct answer. -12.88. In the year 2008, what is the difference between the Gross enrolment ratio (%) in Pre-primary schools and Gross enrolment ratio (%) in Secondary schools?
Give a very brief answer. -7.45. In the year 2008, what is the difference between the Gross enrolment ratio (%) of Pre-primary schools and Gross enrolment ratio (%) of Tertiary schools?
Your answer should be very brief. 29.13. In the year 2008, what is the difference between the Gross enrolment ratio (%) of Primary schools and Gross enrolment ratio (%) of Secondary schools?
Your answer should be very brief. 5.44. In the year 2008, what is the difference between the Gross enrolment ratio (%) in Primary schools and Gross enrolment ratio (%) in Tertiary schools?
Provide a succinct answer. 42.01. In the year 2008, what is the difference between the Gross enrolment ratio (%) in Secondary schools and Gross enrolment ratio (%) in Tertiary schools?
Give a very brief answer. 36.58. What is the ratio of the Gross enrolment ratio (%) of Pre-primary schools in 2002 to that in 2003?
Make the answer very short. 0.99. What is the ratio of the Gross enrolment ratio (%) of Secondary schools in 2002 to that in 2003?
Provide a short and direct response. 0.99. What is the ratio of the Gross enrolment ratio (%) of Tertiary schools in 2002 to that in 2003?
Offer a very short reply. 1.08. What is the ratio of the Gross enrolment ratio (%) of Pre-primary schools in 2002 to that in 2004?
Ensure brevity in your answer.  0.97. What is the ratio of the Gross enrolment ratio (%) in Primary schools in 2002 to that in 2004?
Make the answer very short. 1.01. What is the ratio of the Gross enrolment ratio (%) in Secondary schools in 2002 to that in 2004?
Give a very brief answer. 0.99. What is the ratio of the Gross enrolment ratio (%) in Tertiary schools in 2002 to that in 2004?
Make the answer very short. 0.83. What is the ratio of the Gross enrolment ratio (%) of Pre-primary schools in 2002 to that in 2005?
Your response must be concise. 0.97. What is the ratio of the Gross enrolment ratio (%) in Primary schools in 2002 to that in 2005?
Provide a succinct answer. 1.03. What is the ratio of the Gross enrolment ratio (%) of Secondary schools in 2002 to that in 2005?
Your answer should be compact. 0.98. What is the ratio of the Gross enrolment ratio (%) of Tertiary schools in 2002 to that in 2005?
Keep it short and to the point. 0.78. What is the ratio of the Gross enrolment ratio (%) in Pre-primary schools in 2002 to that in 2006?
Give a very brief answer. 0.95. What is the ratio of the Gross enrolment ratio (%) in Primary schools in 2002 to that in 2006?
Offer a terse response. 1.01. What is the ratio of the Gross enrolment ratio (%) in Secondary schools in 2002 to that in 2006?
Keep it short and to the point. 0.9. What is the ratio of the Gross enrolment ratio (%) in Tertiary schools in 2002 to that in 2006?
Make the answer very short. 0.72. What is the ratio of the Gross enrolment ratio (%) of Pre-primary schools in 2002 to that in 2007?
Make the answer very short. 0.93. What is the ratio of the Gross enrolment ratio (%) in Primary schools in 2002 to that in 2007?
Keep it short and to the point. 1.06. What is the ratio of the Gross enrolment ratio (%) in Secondary schools in 2002 to that in 2007?
Your answer should be very brief. 0.87. What is the ratio of the Gross enrolment ratio (%) of Tertiary schools in 2002 to that in 2007?
Offer a very short reply. 0.74. What is the ratio of the Gross enrolment ratio (%) in Pre-primary schools in 2002 to that in 2008?
Your answer should be very brief. 0.95. What is the ratio of the Gross enrolment ratio (%) of Primary schools in 2002 to that in 2008?
Offer a terse response. 1.06. What is the ratio of the Gross enrolment ratio (%) of Secondary schools in 2002 to that in 2008?
Provide a succinct answer. 0.85. What is the ratio of the Gross enrolment ratio (%) of Tertiary schools in 2002 to that in 2008?
Offer a very short reply. 0.72. What is the ratio of the Gross enrolment ratio (%) in Pre-primary schools in 2003 to that in 2004?
Make the answer very short. 0.97. What is the ratio of the Gross enrolment ratio (%) in Primary schools in 2003 to that in 2004?
Your answer should be compact. 1.01. What is the ratio of the Gross enrolment ratio (%) in Secondary schools in 2003 to that in 2004?
Your answer should be compact. 1. What is the ratio of the Gross enrolment ratio (%) in Tertiary schools in 2003 to that in 2004?
Provide a succinct answer. 0.77. What is the ratio of the Gross enrolment ratio (%) in Pre-primary schools in 2003 to that in 2005?
Make the answer very short. 0.97. What is the ratio of the Gross enrolment ratio (%) in Primary schools in 2003 to that in 2005?
Your answer should be compact. 1.03. What is the ratio of the Gross enrolment ratio (%) in Secondary schools in 2003 to that in 2005?
Give a very brief answer. 0.98. What is the ratio of the Gross enrolment ratio (%) in Tertiary schools in 2003 to that in 2005?
Your answer should be very brief. 0.72. What is the ratio of the Gross enrolment ratio (%) of Pre-primary schools in 2003 to that in 2006?
Give a very brief answer. 0.96. What is the ratio of the Gross enrolment ratio (%) in Primary schools in 2003 to that in 2006?
Give a very brief answer. 1.01. What is the ratio of the Gross enrolment ratio (%) of Secondary schools in 2003 to that in 2006?
Provide a succinct answer. 0.91. What is the ratio of the Gross enrolment ratio (%) in Tertiary schools in 2003 to that in 2006?
Provide a succinct answer. 0.67. What is the ratio of the Gross enrolment ratio (%) in Pre-primary schools in 2003 to that in 2007?
Provide a succinct answer. 0.94. What is the ratio of the Gross enrolment ratio (%) in Primary schools in 2003 to that in 2007?
Ensure brevity in your answer.  1.06. What is the ratio of the Gross enrolment ratio (%) in Secondary schools in 2003 to that in 2007?
Your response must be concise. 0.87. What is the ratio of the Gross enrolment ratio (%) of Tertiary schools in 2003 to that in 2007?
Give a very brief answer. 0.69. What is the ratio of the Gross enrolment ratio (%) of Pre-primary schools in 2003 to that in 2008?
Give a very brief answer. 0.95. What is the ratio of the Gross enrolment ratio (%) in Primary schools in 2003 to that in 2008?
Your answer should be compact. 1.06. What is the ratio of the Gross enrolment ratio (%) of Secondary schools in 2003 to that in 2008?
Your answer should be compact. 0.86. What is the ratio of the Gross enrolment ratio (%) of Tertiary schools in 2003 to that in 2008?
Give a very brief answer. 0.67. What is the ratio of the Gross enrolment ratio (%) in Primary schools in 2004 to that in 2005?
Make the answer very short. 1.02. What is the ratio of the Gross enrolment ratio (%) in Secondary schools in 2004 to that in 2005?
Your answer should be compact. 0.98. What is the ratio of the Gross enrolment ratio (%) of Tertiary schools in 2004 to that in 2005?
Offer a very short reply. 0.94. What is the ratio of the Gross enrolment ratio (%) in Pre-primary schools in 2004 to that in 2006?
Your response must be concise. 0.98. What is the ratio of the Gross enrolment ratio (%) in Secondary schools in 2004 to that in 2006?
Offer a terse response. 0.91. What is the ratio of the Gross enrolment ratio (%) of Tertiary schools in 2004 to that in 2006?
Provide a succinct answer. 0.87. What is the ratio of the Gross enrolment ratio (%) of Pre-primary schools in 2004 to that in 2007?
Your answer should be compact. 0.97. What is the ratio of the Gross enrolment ratio (%) in Primary schools in 2004 to that in 2007?
Give a very brief answer. 1.05. What is the ratio of the Gross enrolment ratio (%) of Secondary schools in 2004 to that in 2007?
Give a very brief answer. 0.88. What is the ratio of the Gross enrolment ratio (%) of Tertiary schools in 2004 to that in 2007?
Provide a succinct answer. 0.89. What is the ratio of the Gross enrolment ratio (%) in Pre-primary schools in 2004 to that in 2008?
Provide a short and direct response. 0.98. What is the ratio of the Gross enrolment ratio (%) of Primary schools in 2004 to that in 2008?
Your answer should be very brief. 1.05. What is the ratio of the Gross enrolment ratio (%) of Secondary schools in 2004 to that in 2008?
Provide a succinct answer. 0.86. What is the ratio of the Gross enrolment ratio (%) of Tertiary schools in 2004 to that in 2008?
Keep it short and to the point. 0.87. What is the ratio of the Gross enrolment ratio (%) of Pre-primary schools in 2005 to that in 2006?
Ensure brevity in your answer.  0.98. What is the ratio of the Gross enrolment ratio (%) in Primary schools in 2005 to that in 2006?
Offer a very short reply. 0.99. What is the ratio of the Gross enrolment ratio (%) in Secondary schools in 2005 to that in 2006?
Your response must be concise. 0.92. What is the ratio of the Gross enrolment ratio (%) in Tertiary schools in 2005 to that in 2006?
Provide a short and direct response. 0.93. What is the ratio of the Gross enrolment ratio (%) in Pre-primary schools in 2005 to that in 2007?
Provide a short and direct response. 0.97. What is the ratio of the Gross enrolment ratio (%) in Primary schools in 2005 to that in 2007?
Your answer should be very brief. 1.03. What is the ratio of the Gross enrolment ratio (%) of Secondary schools in 2005 to that in 2007?
Make the answer very short. 0.89. What is the ratio of the Gross enrolment ratio (%) of Tertiary schools in 2005 to that in 2007?
Offer a very short reply. 0.95. What is the ratio of the Gross enrolment ratio (%) in Pre-primary schools in 2005 to that in 2008?
Provide a short and direct response. 0.98. What is the ratio of the Gross enrolment ratio (%) in Primary schools in 2005 to that in 2008?
Your answer should be compact. 1.03. What is the ratio of the Gross enrolment ratio (%) in Secondary schools in 2005 to that in 2008?
Offer a terse response. 0.88. What is the ratio of the Gross enrolment ratio (%) of Tertiary schools in 2005 to that in 2008?
Provide a short and direct response. 0.92. What is the ratio of the Gross enrolment ratio (%) in Pre-primary schools in 2006 to that in 2007?
Your answer should be compact. 0.98. What is the ratio of the Gross enrolment ratio (%) in Primary schools in 2006 to that in 2007?
Your answer should be very brief. 1.04. What is the ratio of the Gross enrolment ratio (%) in Secondary schools in 2006 to that in 2007?
Offer a terse response. 0.96. What is the ratio of the Gross enrolment ratio (%) of Tertiary schools in 2006 to that in 2007?
Offer a very short reply. 1.03. What is the ratio of the Gross enrolment ratio (%) in Primary schools in 2006 to that in 2008?
Your response must be concise. 1.05. What is the ratio of the Gross enrolment ratio (%) in Secondary schools in 2006 to that in 2008?
Ensure brevity in your answer.  0.95. What is the ratio of the Gross enrolment ratio (%) of Pre-primary schools in 2007 to that in 2008?
Offer a very short reply. 1.01. What is the ratio of the Gross enrolment ratio (%) in Secondary schools in 2007 to that in 2008?
Ensure brevity in your answer.  0.98. What is the ratio of the Gross enrolment ratio (%) of Tertiary schools in 2007 to that in 2008?
Provide a succinct answer. 0.97. What is the difference between the highest and the second highest Gross enrolment ratio (%) in Pre-primary schools?
Your answer should be very brief. 1.07. What is the difference between the highest and the second highest Gross enrolment ratio (%) in Primary schools?
Your response must be concise. 0.18. What is the difference between the highest and the second highest Gross enrolment ratio (%) in Secondary schools?
Keep it short and to the point. 1.71. What is the difference between the highest and the second highest Gross enrolment ratio (%) in Tertiary schools?
Your answer should be very brief. 0.06. What is the difference between the highest and the lowest Gross enrolment ratio (%) in Pre-primary schools?
Give a very brief answer. 6.03. What is the difference between the highest and the lowest Gross enrolment ratio (%) in Primary schools?
Make the answer very short. 6.26. What is the difference between the highest and the lowest Gross enrolment ratio (%) of Secondary schools?
Offer a very short reply. 14.28. What is the difference between the highest and the lowest Gross enrolment ratio (%) in Tertiary schools?
Your answer should be compact. 20.31. 